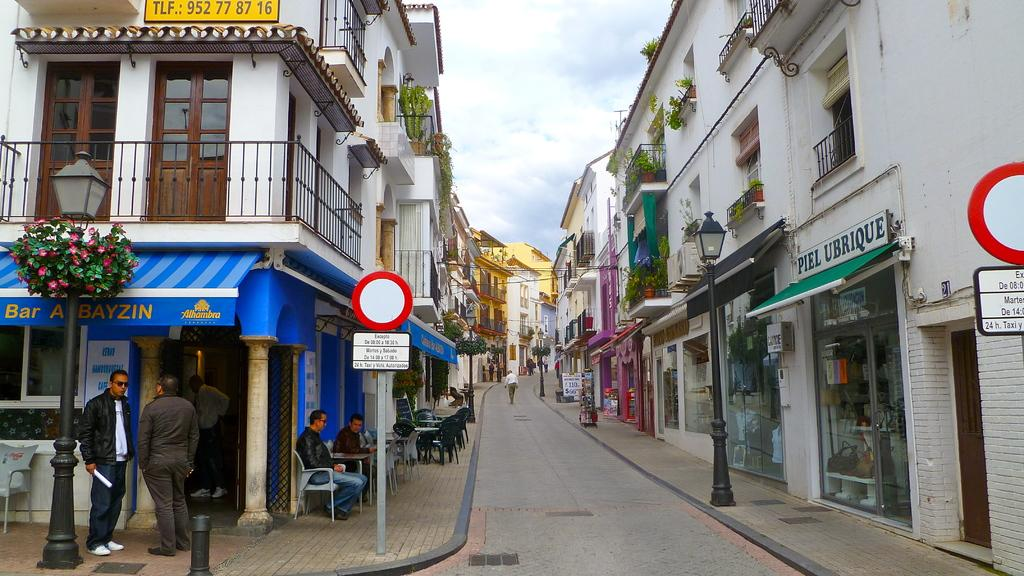What type of structures can be seen in the image? There are buildings in the image. What are the vertical objects in the image? There are poles in the image. What flat objects can be seen in the image? There are boards in the image. What type of vegetation is present in the image? There are plants and flowers in the image. What type of barrier is visible in the image? There is a fence in the image. What type of furniture is present in the image? There are chairs and tables in the image. Are there any people in the image? Yes, there are people in the image. What type of pathway is visible in the image? There is a road in the image. What can be seen in the sky in the image? There are clouds in the sky. What type of muscle can be seen flexing in the image? There is no muscle visible in the image. What type of bag is being carried by the people in the image? There is no bag being carried by the people in the image. What type of tooth is visible in the image? There are no teeth visible in the image. 